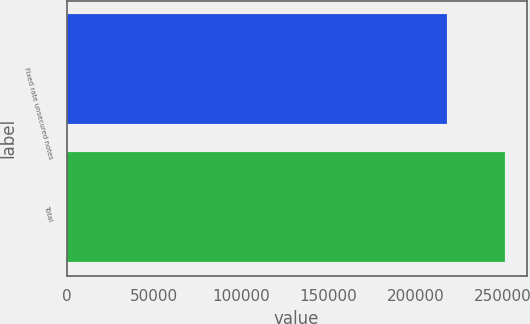<chart> <loc_0><loc_0><loc_500><loc_500><bar_chart><fcel>Fixed rate unsecured notes<fcel>Total<nl><fcel>218032<fcel>250925<nl></chart> 